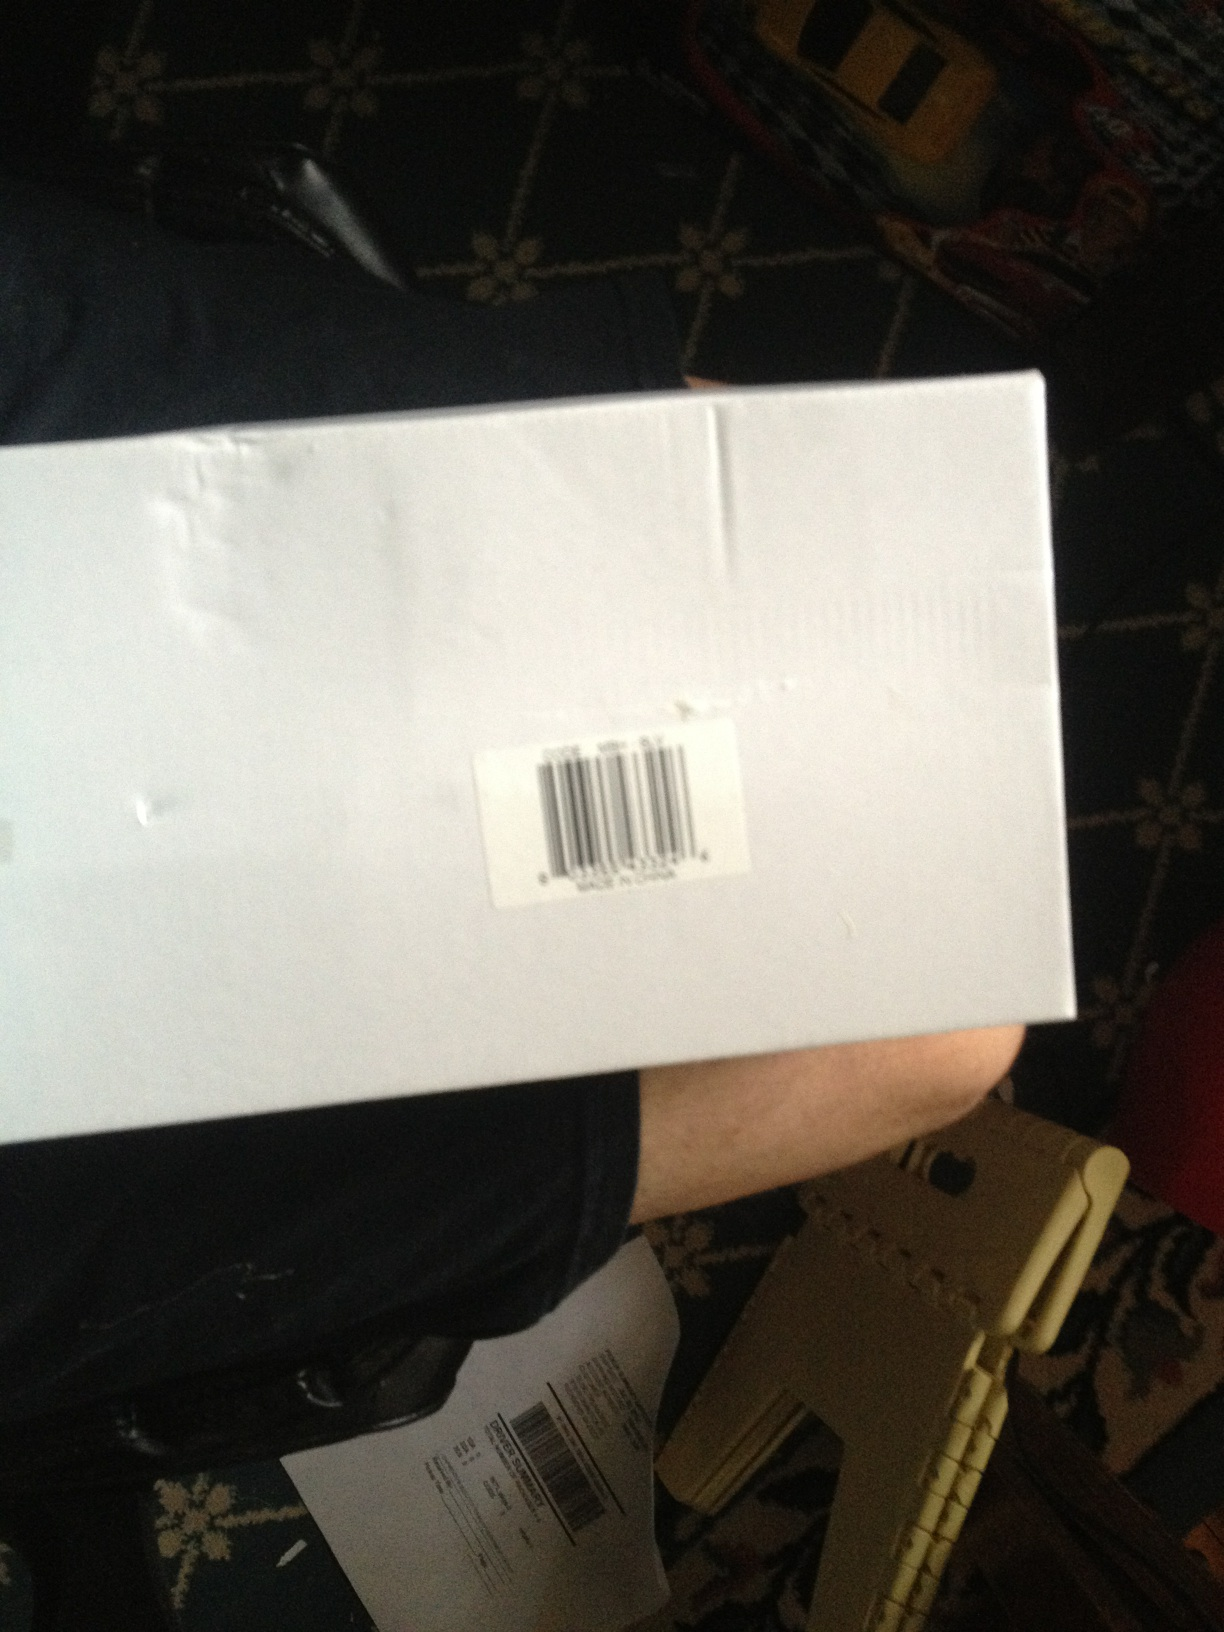Can you describe the condition of this box? The box appears to be in fairly good condition with some minor creases and dents, indicating it has been handled but is still intact and suitable for use. 